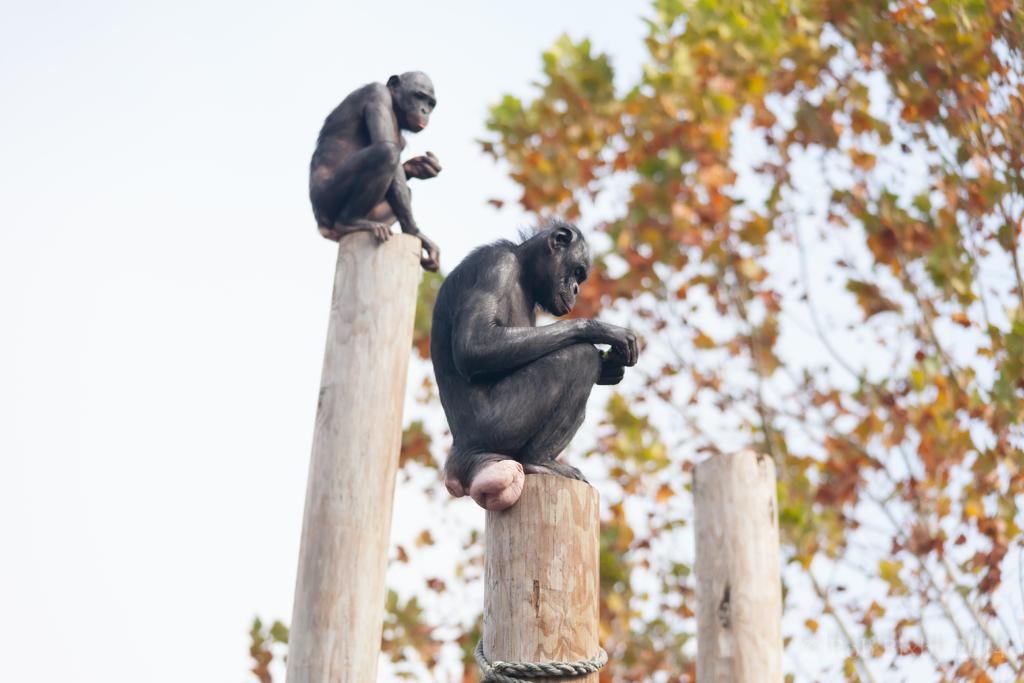How many monkeys are in the image? There are two monkeys in the image. What are the monkeys sitting on? The monkeys are sitting on wooden poles. Is there any additional feature attached to the wooden poles? Yes, there is a rope tied to one of the poles. What can be seen in the background of the image? There is a wooden pole, a tree, and the sky visible in the background of the image. What type of gold jewelry can be seen on the monkeys in the image? There is no gold jewelry present on the monkeys in the image. Can you tell me how the monkeys are swimming in the image? The monkeys are not swimming in the image; they are sitting on wooden poles. 